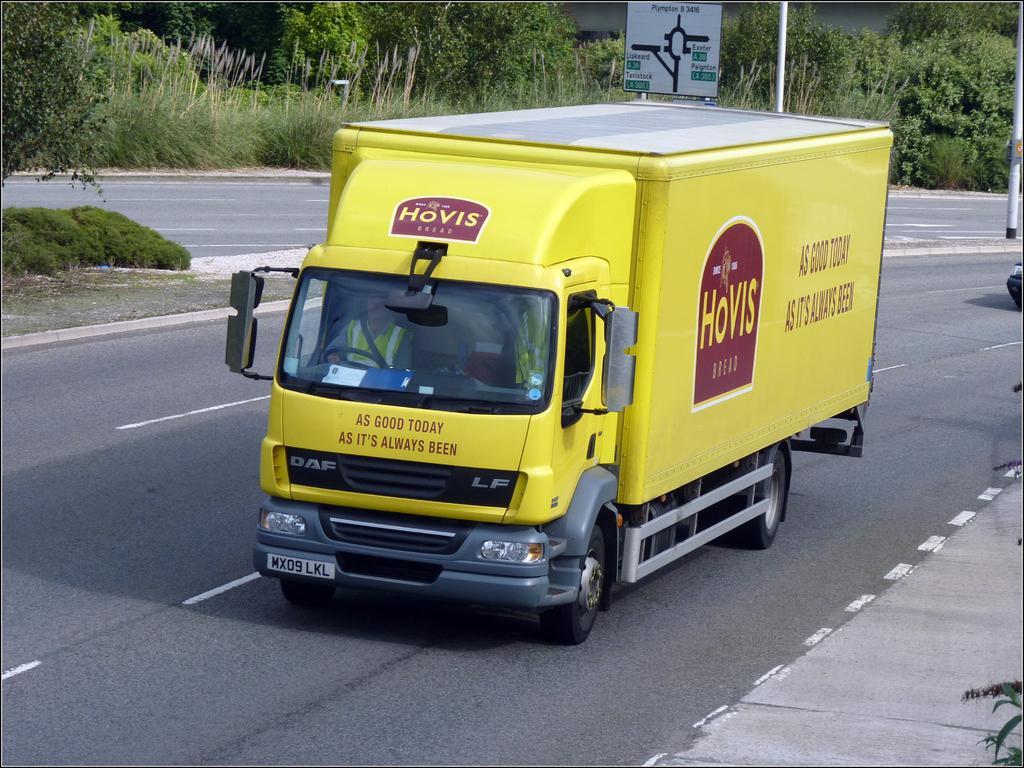Please provide a concise description of this image. In this image there are two vehicles moving on the road. In the middle of the road there is a sign board, a pole and some grass. In the background there are trees and plants. 